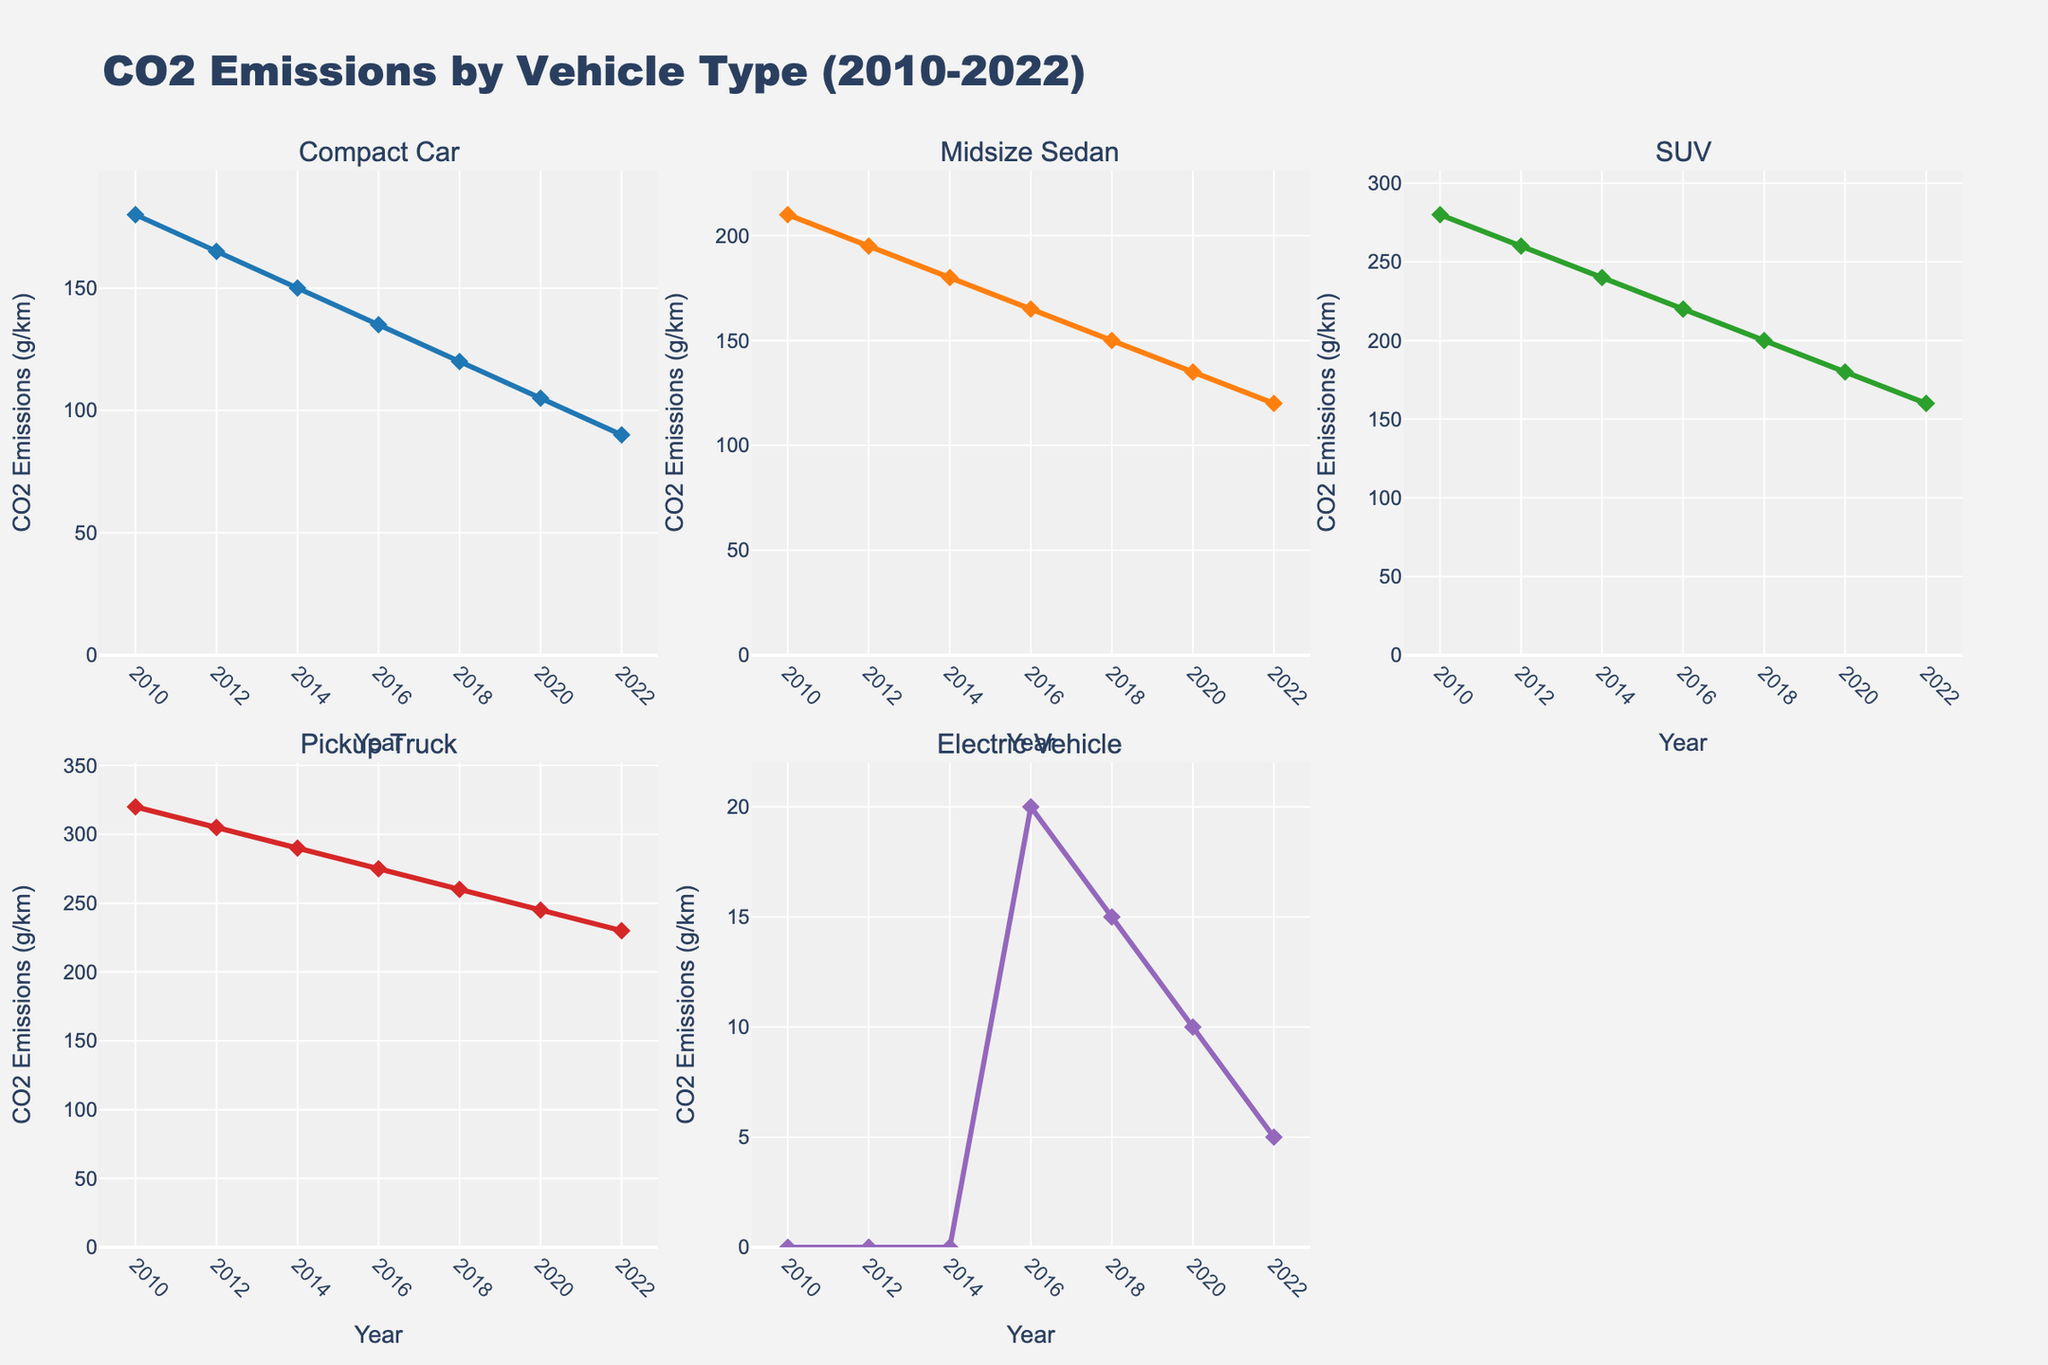What's the title of the figure? The title is usually displayed prominently at the top of a figure. In this subplot, the title is "CO2 Emissions by Vehicle Type (2010-2022)"
Answer: CO2 Emissions by Vehicle Type (2010-2022) What is the value of CO2 emissions for SUVs in 2018? Locate the subplot for SUVs, find the data point corresponding to the year 2018. The value is 200 g/km.
Answer: 200 g/km Which vehicle type had the highest CO2 emissions in 2020? Examine the 2020 data points across all subplots. The values are: Compact Car (105), Midsize Sedan (135), SUV (180), Pickup Truck (245), Electric Vehicle (10). Pickup Truck has the highest value.
Answer: Pickup Truck Have the CO2 emissions for Electric Vehicles increased or decreased from 2016 to 2022? Compare the CO2 emissions data points for Electric Vehicles in 2016 (20 g/km) and 2022 (5 g/km). There is a decrease.
Answer: Decreased Which vehicle type experienced the largest percentage reduction in CO2 emissions from 2010 to 2022? Calculate the percentage reduction for each vehicle type:  
Compact Car: (180-90)/180 * 100 = 50%  
Midsize Sedan: (210-120)/210 * 100 = 43%  
SUV: (280-160)/280 * 100 = 43%  
Pickup Truck: (320-230)/320 * 100 = 28%  
Electric Vehicle: (0-5)/0 is not applicable because the starting value is zero  
Compact Car has the largest percentage reduction.
Answer: Compact Car What is the average CO2 emission for Midsize Sedans across all years? Sum the CO2 emissions for Midsize Sedans for each year and divide by the number of years: (210 + 195 + 180 + 165 + 150 + 135 + 120) / 7 = 165 g/km
Answer: 165 g/km In which year did Compact Cars emit less than 150 g/km for the first time? Look at the data points for Compact Cars and identify the first year when the emission is less than 150 g/km. This occurs in 2016 with an emission of 135 g/km.
Answer: 2016 Which two vehicle types had the closest CO2 emissions in 2014 and what were those values? Identify the CO2 emissions for each vehicle type in 2014: Compact Car (150), Midsize Sedan (180), SUV (240), Pickup Truck (290), Electric Vehicle (0). Compact Car and Midsize Sedan have the closest values (150 and 180, respectively).
Answer: Compact Car and Midsize Sedan (150 and 180) What is the overall trend of CO2 emissions for Pickup Trucks from 2010 to 2022? Identify the data points for Pickup Trucks across the years: 320, 305, 290, 275, 260, 245, 230 g/km. There is a consistent downward trend.
Answer: Downward trend How did the CO2 emissions for SUVs compare between 2012 and 2018? Check the CO2 emissions data for SUVs in 2012 (260 g/km) and 2018 (200 g/km). Emissions decreased by 60 g/km.
Answer: Decreased by 60 g/km 